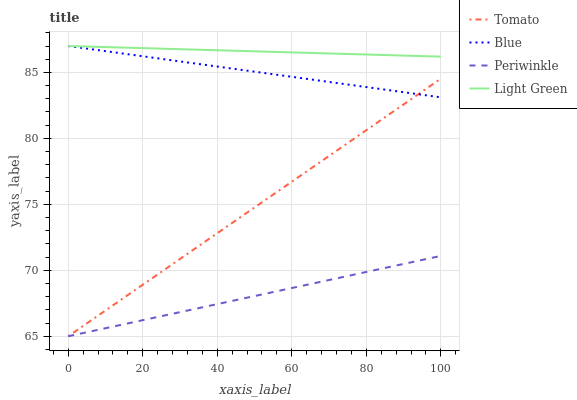Does Periwinkle have the minimum area under the curve?
Answer yes or no. Yes. Does Light Green have the maximum area under the curve?
Answer yes or no. Yes. Does Blue have the minimum area under the curve?
Answer yes or no. No. Does Blue have the maximum area under the curve?
Answer yes or no. No. Is Tomato the smoothest?
Answer yes or no. Yes. Is Light Green the roughest?
Answer yes or no. Yes. Is Blue the smoothest?
Answer yes or no. No. Is Blue the roughest?
Answer yes or no. No. Does Tomato have the lowest value?
Answer yes or no. Yes. Does Blue have the lowest value?
Answer yes or no. No. Does Light Green have the highest value?
Answer yes or no. Yes. Does Periwinkle have the highest value?
Answer yes or no. No. Is Periwinkle less than Light Green?
Answer yes or no. Yes. Is Light Green greater than Periwinkle?
Answer yes or no. Yes. Does Periwinkle intersect Tomato?
Answer yes or no. Yes. Is Periwinkle less than Tomato?
Answer yes or no. No. Is Periwinkle greater than Tomato?
Answer yes or no. No. Does Periwinkle intersect Light Green?
Answer yes or no. No. 